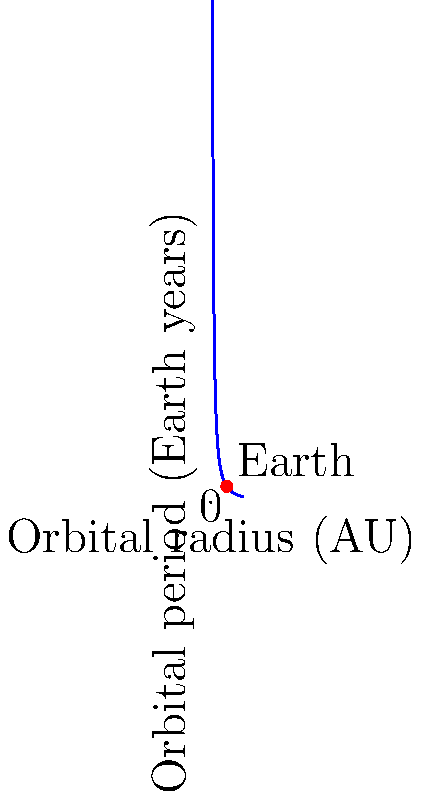An exoplanet orbiting a star with the same mass as our Sun is discovered. Its orbital radius is measured to be 0.5 AU. Using Kepler's Third Law and the graph provided, estimate the orbital period of this exoplanet in Earth years. How might this discovery impact our understanding of planetary formation in different stellar environments? To solve this problem, we'll use Kepler's Third Law and the information provided in the graph:

1) Kepler's Third Law states that $T^2 \propto a^3$, where $T$ is the orbital period and $a$ is the orbital radius.

2) For a star with the same mass as our Sun, we can write:

   $\frac{T^2}{a^3} = \frac{T_{\text{Earth}}^2}{a_{\text{Earth}}^3} = 1 \text{ year}^2 / \text{AU}^3$

3) The graph shows $T = \frac{1}{\sqrt{a^3}}$, which is consistent with Kepler's Third Law when $T$ is in Earth years and $a$ is in AU.

4) For the exoplanet, $a = 0.5 \text{ AU}$. We can substitute this into the equation:

   $T = \frac{1}{\sqrt{(0.5)^3}} = \frac{1}{\sqrt{0.125}} = \frac{1}{0.3536} \approx 2.83 \text{ Earth years}$

5) We can verify this on the graph: at $x = 0.5$, $y$ is slightly less than 3.

This discovery impacts our understanding of planetary formation by:
- Demonstrating that planets can form and maintain stable orbits closer to their stars than Earth is to the Sun.
- Suggesting that planetary migration or in-situ formation may occur in diverse stellar environments.
- Providing data to refine models of protoplanetary disk evolution and planet-disk interactions.
- Offering insights into the potential habitability of planets in different orbital configurations.
Answer: $\approx 2.83 \text{ Earth years}$ 